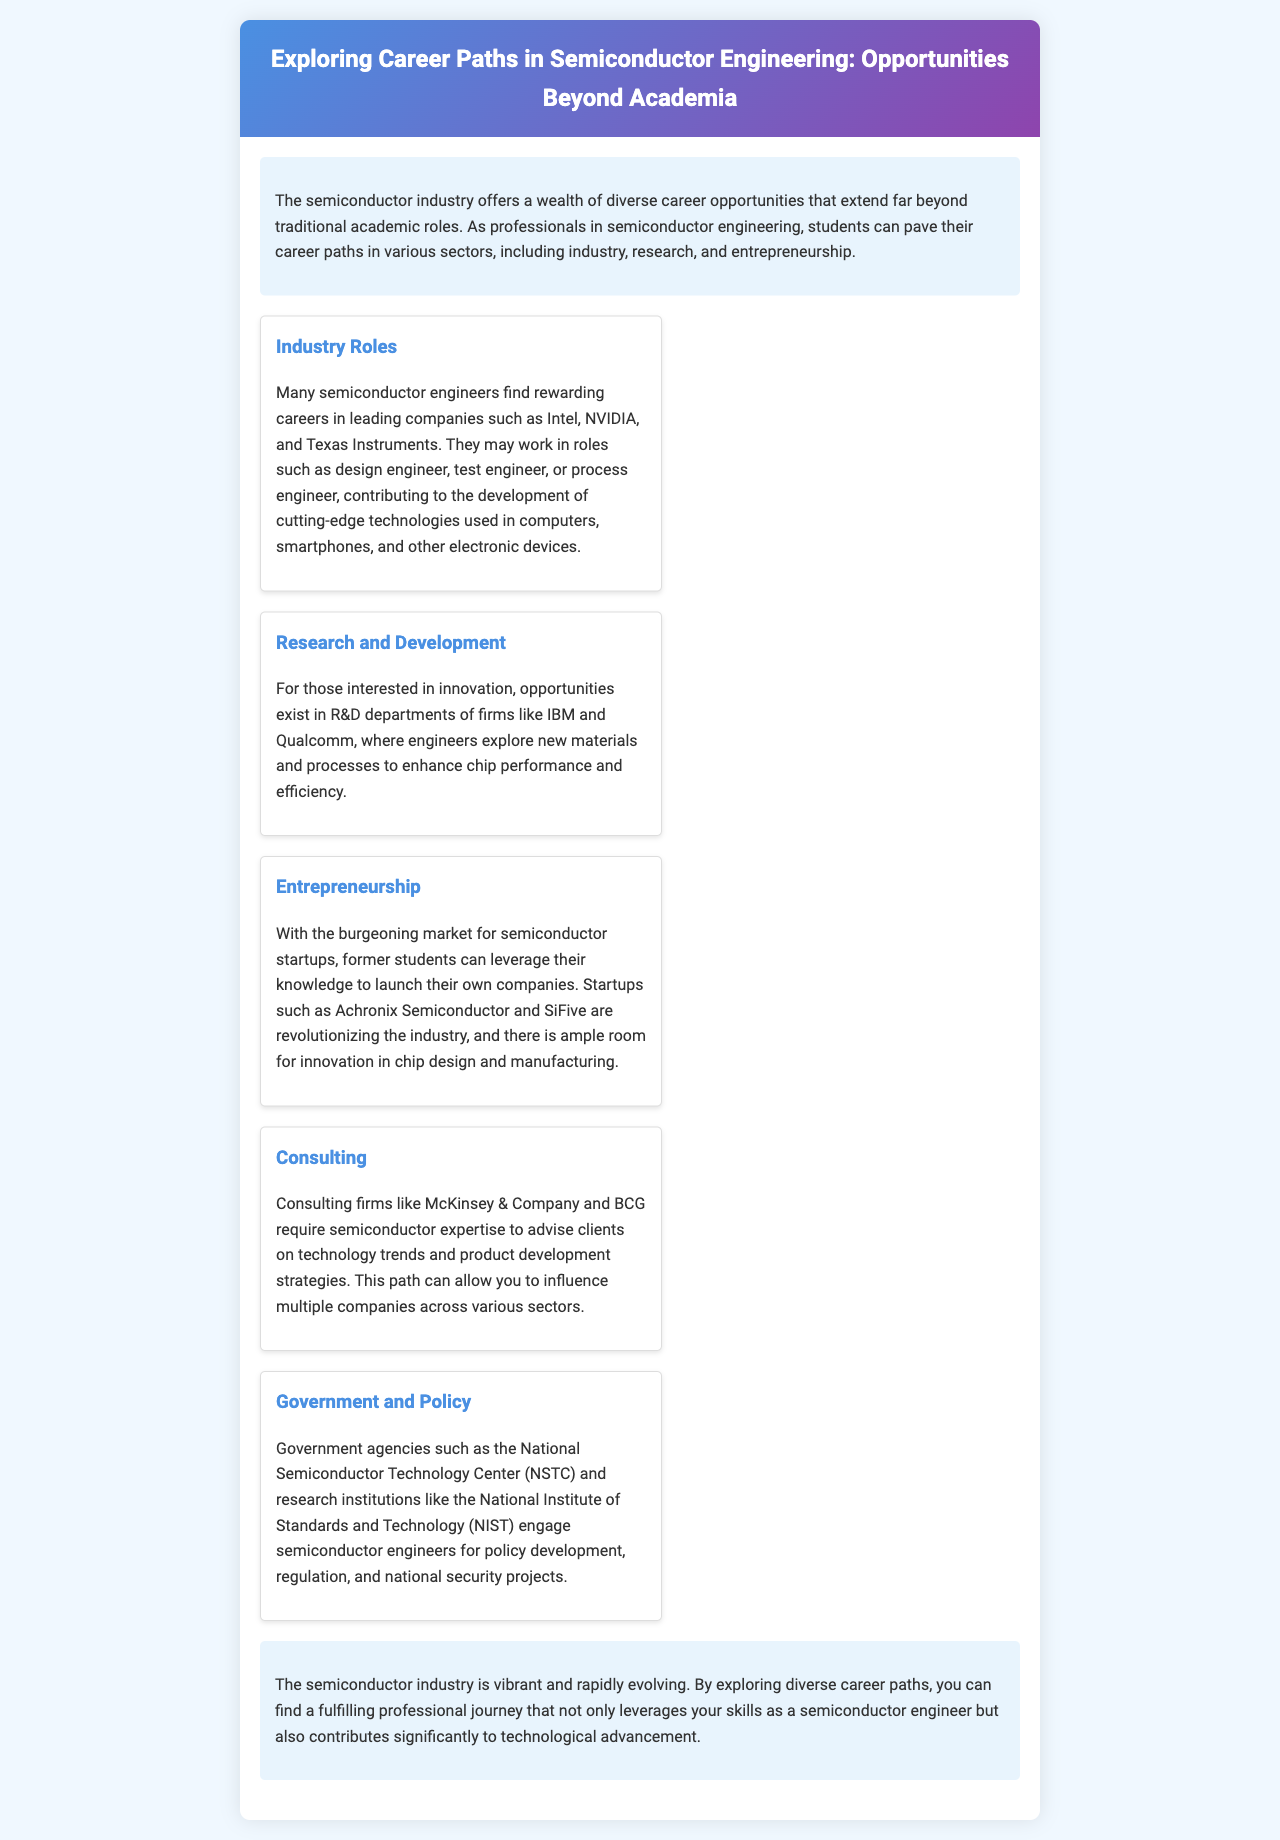What is the title of the brochure? The title is specified in the header section of the document.
Answer: Exploring Career Paths in Semiconductor Engineering: Opportunities Beyond Academia What are three roles mentioned in industry careers? Three roles are specified in the industry careers section of the document.
Answer: design engineer, test engineer, process engineer Which companies are noted for research and development opportunities? The companies mentioned in the R&D section are detailed in the document.
Answer: IBM, Qualcomm What is a career path option for engineers interested in technology trends? This information is found in the consulting section of the brochure.
Answer: Consulting Name a startup mentioned in the entrepreneurship section. The startup is explicitly stated in the entrepreneurship career path of the document.
Answer: Achronix Semiconductor According to the document, which government agency engages semiconductor engineers? The agency is listed in the government and policy career path focused on semiconductor engineering.
Answer: National Semiconductor Technology Center What color scheme is used in the brochure's header? The brochure's header background is described in the style section.
Answer: Linear-gradient of blue and purple What is the main focus of the document? The main focus can be inferred from the introduction section.
Answer: Diverse career opportunities beyond academia 